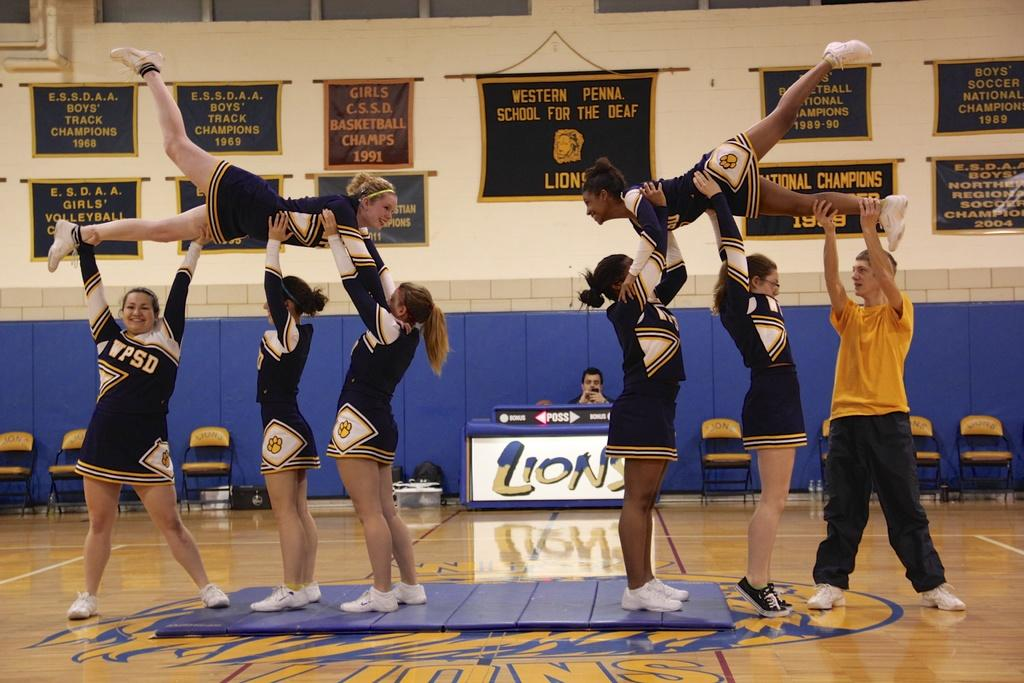<image>
Summarize the visual content of the image. the word Lions is next to the cheerleaders 